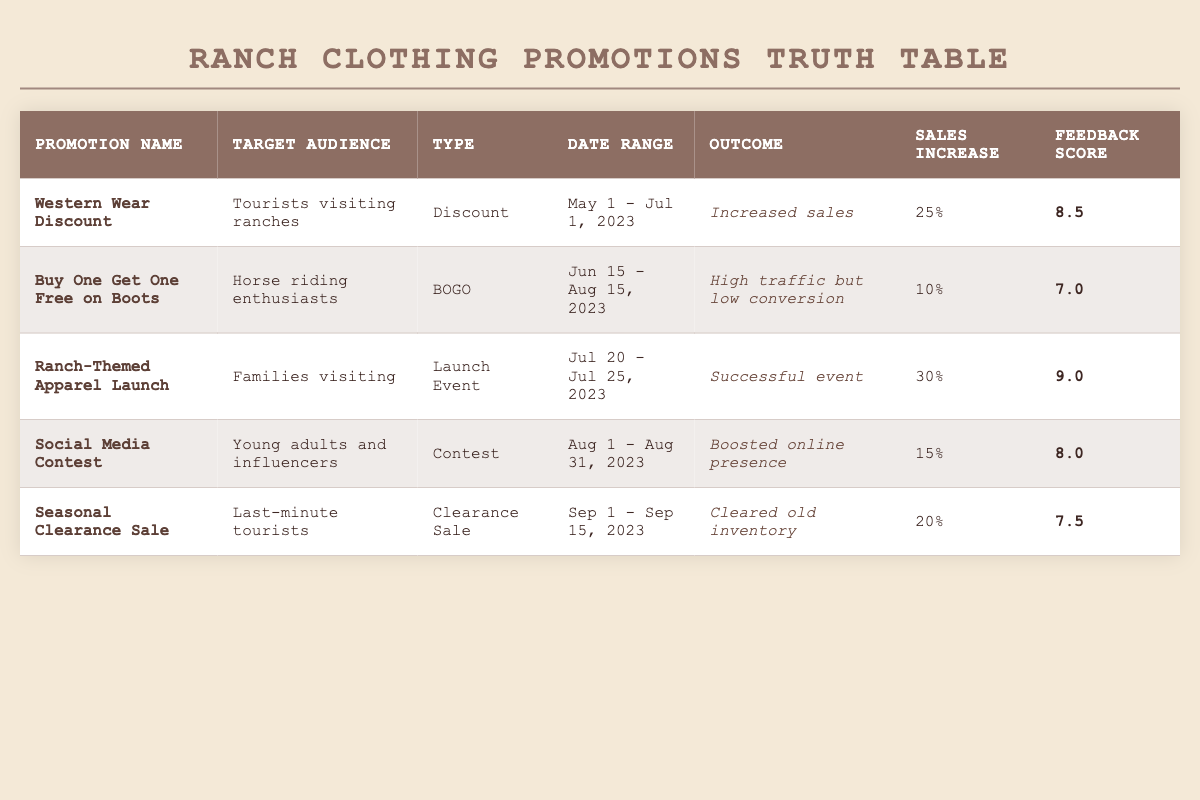What is the promotion name with the highest sales increase percentage? The highest sales increase percentage in the table is 30%, which corresponds to the promotion "Ranch-Themed Apparel Launch."
Answer: Ranch-Themed Apparel Launch Which promotion had the lowest customer feedback score? The lowest customer feedback score in the table is 7.0, found in the promotion "Buy One Get One Free on Boots."
Answer: Buy One Get One Free on Boots What is the average sales increase percentage of all promotions targeting tourists? The promotions targeting tourists are "Western Wear Discount" (25%) and "Seasonal Clearance Sale" (20%). The average is (25 + 20) / 2 = 22.5%.
Answer: 22.5% Did the "Social Media Contest" result in increased sales? The outcome for "Social Media Contest" is listed as "Boosted online presence," indicating that it did not specifically result in increased sales.
Answer: No What is the date range for the "Western Wear Discount" promotion? The "Western Wear Discount" promotion runs from May 1 to July 1, 2023, as specified in the table.
Answer: May 1 - July 1, 2023 Which promotion had the highest customer feedback score? The highest customer feedback score in the table is 9.0, associated with the "Ranch-Themed Apparel Launch."
Answer: Ranch-Themed Apparel Launch How many promotions resulted in a successful outcome? Two promotions had a successful outcome: "Western Wear Discount" (Increased sales) and "Ranch-Themed Apparel Launch" (Successful event).
Answer: 2 What promotion type had the highest sales increase percentage? The promotion type with the highest sales increase percentage is "Launch Event" from "Ranch-Themed Apparel Launch" with a 30% sales increase.
Answer: Launch Event Is the "Seasonal Clearance Sale" aimed at last-minute tourists? Yes, the "Seasonal Clearance Sale" specifically targets last-minute tourists.
Answer: Yes 